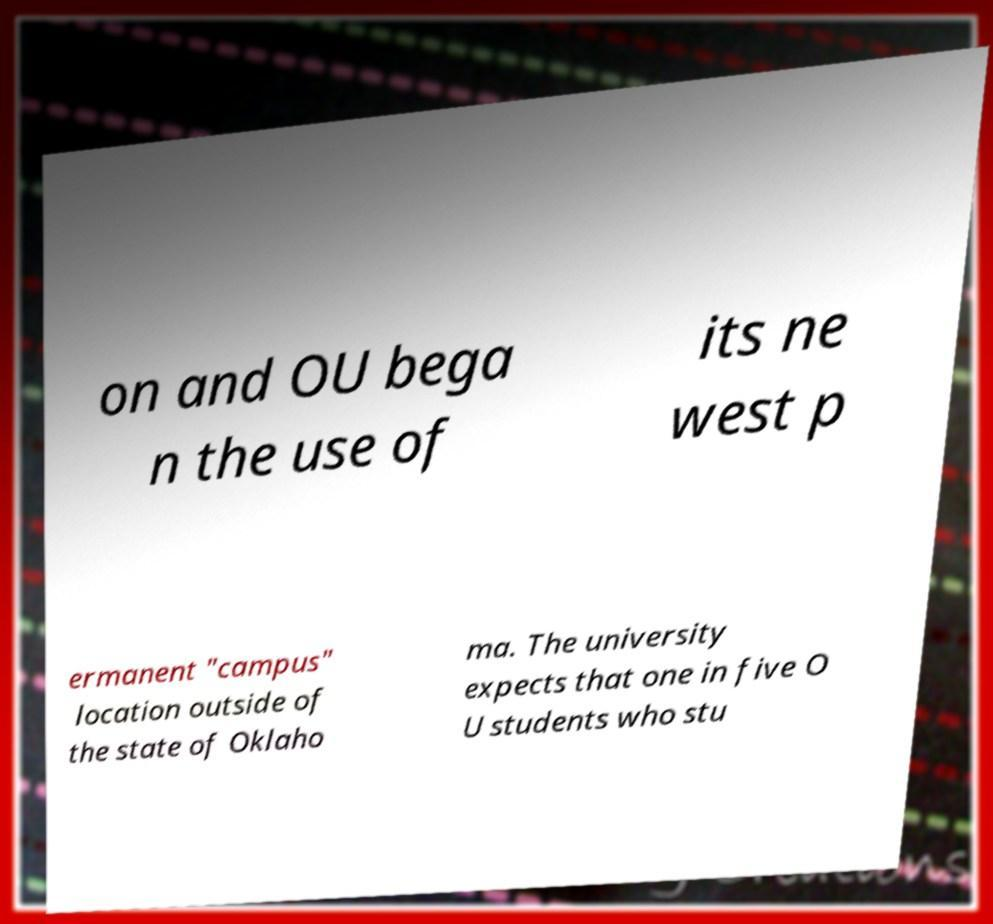I need the written content from this picture converted into text. Can you do that? on and OU bega n the use of its ne west p ermanent "campus" location outside of the state of Oklaho ma. The university expects that one in five O U students who stu 